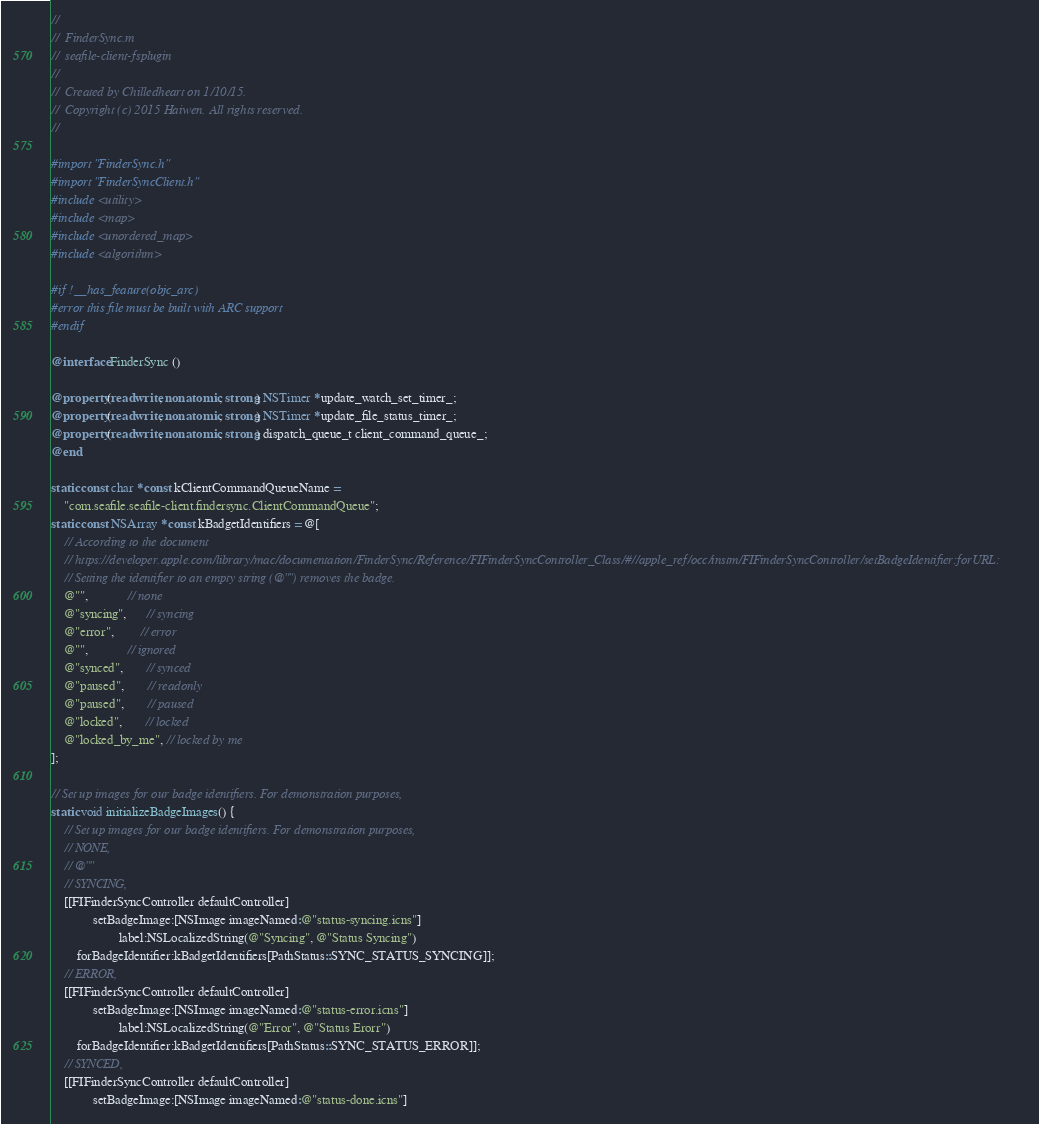<code> <loc_0><loc_0><loc_500><loc_500><_ObjectiveC_>//
//  FinderSync.m
//  seafile-client-fsplugin
//
//  Created by Chilledheart on 1/10/15.
//  Copyright (c) 2015 Haiwen. All rights reserved.
//

#import "FinderSync.h"
#import "FinderSyncClient.h"
#include <utility>
#include <map>
#include <unordered_map>
#include <algorithm>

#if !__has_feature(objc_arc)
#error this file must be built with ARC support
#endif

@interface FinderSync ()

@property(readwrite, nonatomic, strong) NSTimer *update_watch_set_timer_;
@property(readwrite, nonatomic, strong) NSTimer *update_file_status_timer_;
@property(readwrite, nonatomic, strong) dispatch_queue_t client_command_queue_;
@end

static const char *const kClientCommandQueueName =
    "com.seafile.seafile-client.findersync.ClientCommandQueue";
static const NSArray *const kBadgetIdentifiers = @[
    // According to the document
    // https://developer.apple.com/library/mac/documentation/FinderSync/Reference/FIFinderSyncController_Class/#//apple_ref/occ/instm/FIFinderSyncController/setBadgeIdentifier:forURL:
    // Setting the identifier to an empty string (@"") removes the badge.
    @"",            // none
    @"syncing",      // syncing
    @"error",        // error
    @"",            // ignored
    @"synced",       // synced
    @"paused",       // readonly
    @"paused",       // paused
    @"locked",       // locked
    @"locked_by_me", // locked by me
];

// Set up images for our badge identifiers. For demonstration purposes,
static void initializeBadgeImages() {
    // Set up images for our badge identifiers. For demonstration purposes,
    // NONE,
    // @""
    // SYNCING,
    [[FIFinderSyncController defaultController]
             setBadgeImage:[NSImage imageNamed:@"status-syncing.icns"]
                     label:NSLocalizedString(@"Syncing", @"Status Syncing")
        forBadgeIdentifier:kBadgetIdentifiers[PathStatus::SYNC_STATUS_SYNCING]];
    // ERROR,
    [[FIFinderSyncController defaultController]
             setBadgeImage:[NSImage imageNamed:@"status-error.icns"]
                     label:NSLocalizedString(@"Error", @"Status Erorr")
        forBadgeIdentifier:kBadgetIdentifiers[PathStatus::SYNC_STATUS_ERROR]];
    // SYNCED,
    [[FIFinderSyncController defaultController]
             setBadgeImage:[NSImage imageNamed:@"status-done.icns"]</code> 